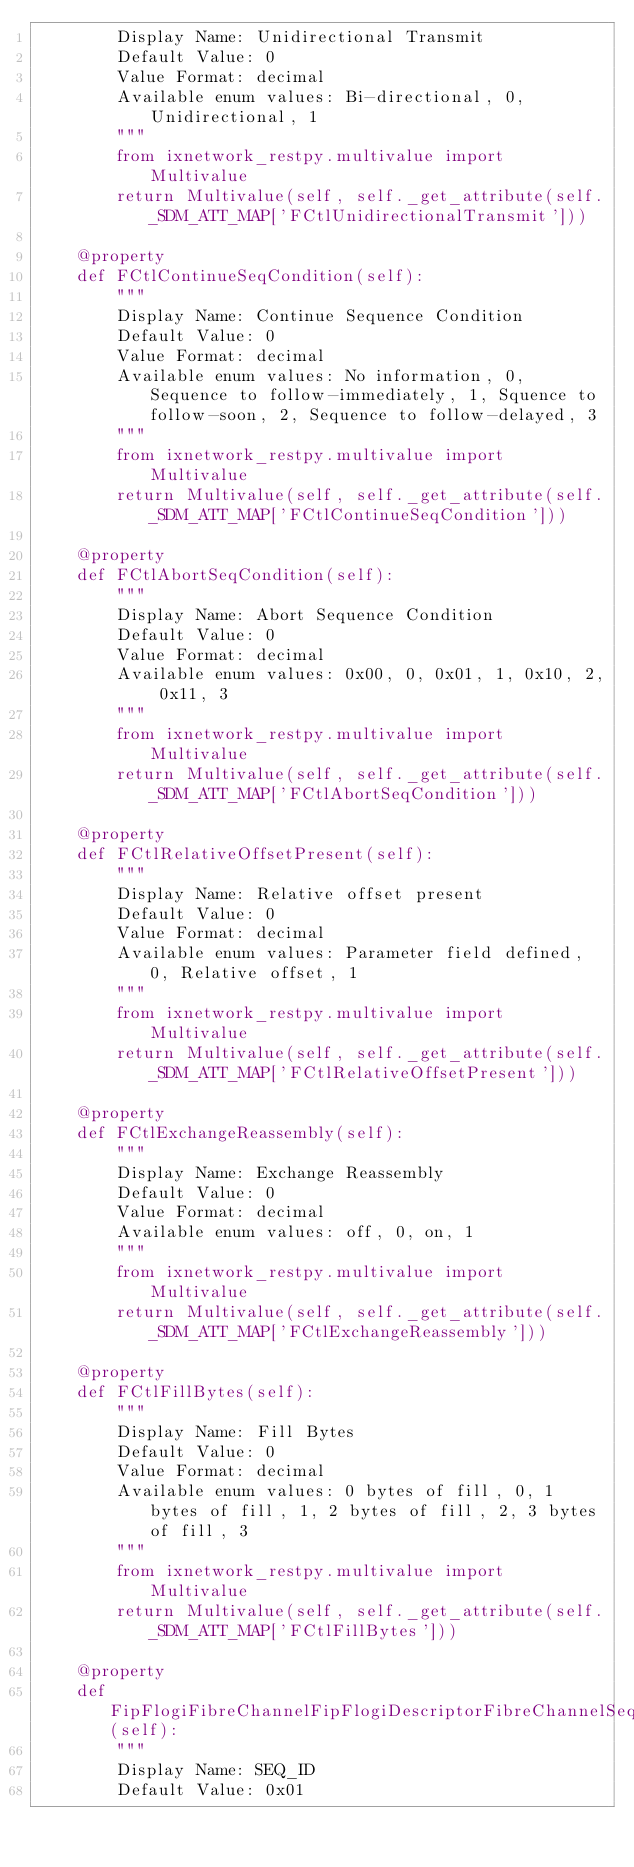Convert code to text. <code><loc_0><loc_0><loc_500><loc_500><_Python_>        Display Name: Unidirectional Transmit
        Default Value: 0
        Value Format: decimal
        Available enum values: Bi-directional, 0, Unidirectional, 1
        """
        from ixnetwork_restpy.multivalue import Multivalue
        return Multivalue(self, self._get_attribute(self._SDM_ATT_MAP['FCtlUnidirectionalTransmit']))

    @property
    def FCtlContinueSeqCondition(self):
        """
        Display Name: Continue Sequence Condition
        Default Value: 0
        Value Format: decimal
        Available enum values: No information, 0, Sequence to follow-immediately, 1, Squence to follow-soon, 2, Sequence to follow-delayed, 3
        """
        from ixnetwork_restpy.multivalue import Multivalue
        return Multivalue(self, self._get_attribute(self._SDM_ATT_MAP['FCtlContinueSeqCondition']))

    @property
    def FCtlAbortSeqCondition(self):
        """
        Display Name: Abort Sequence Condition
        Default Value: 0
        Value Format: decimal
        Available enum values: 0x00, 0, 0x01, 1, 0x10, 2, 0x11, 3
        """
        from ixnetwork_restpy.multivalue import Multivalue
        return Multivalue(self, self._get_attribute(self._SDM_ATT_MAP['FCtlAbortSeqCondition']))

    @property
    def FCtlRelativeOffsetPresent(self):
        """
        Display Name: Relative offset present
        Default Value: 0
        Value Format: decimal
        Available enum values: Parameter field defined, 0, Relative offset, 1
        """
        from ixnetwork_restpy.multivalue import Multivalue
        return Multivalue(self, self._get_attribute(self._SDM_ATT_MAP['FCtlRelativeOffsetPresent']))

    @property
    def FCtlExchangeReassembly(self):
        """
        Display Name: Exchange Reassembly
        Default Value: 0
        Value Format: decimal
        Available enum values: off, 0, on, 1
        """
        from ixnetwork_restpy.multivalue import Multivalue
        return Multivalue(self, self._get_attribute(self._SDM_ATT_MAP['FCtlExchangeReassembly']))

    @property
    def FCtlFillBytes(self):
        """
        Display Name: Fill Bytes
        Default Value: 0
        Value Format: decimal
        Available enum values: 0 bytes of fill, 0, 1 bytes of fill, 1, 2 bytes of fill, 2, 3 bytes of fill, 3
        """
        from ixnetwork_restpy.multivalue import Multivalue
        return Multivalue(self, self._get_attribute(self._SDM_ATT_MAP['FCtlFillBytes']))

    @property
    def FipFlogiFibreChannelFipFlogiDescriptorFibreChannelSeqId(self):
        """
        Display Name: SEQ_ID
        Default Value: 0x01</code> 